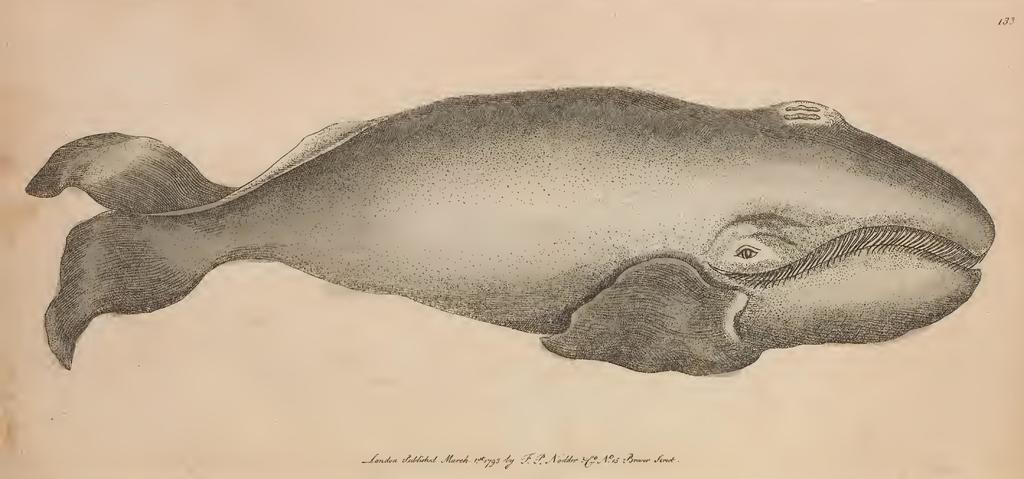Can you describe this image briefly? In this image in the foreground it looks like a sketch of a fish. 